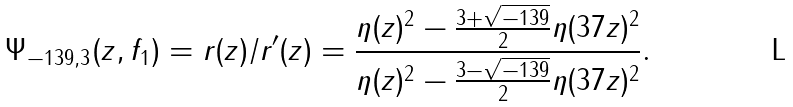Convert formula to latex. <formula><loc_0><loc_0><loc_500><loc_500>\Psi _ { - 1 3 9 , 3 } ( z , f _ { 1 } ) = r ( z ) / r ^ { \prime } ( z ) = \frac { \eta ( z ) ^ { 2 } - \frac { 3 + \sqrt { - 1 3 9 } } { 2 } \eta ( 3 7 z ) ^ { 2 } } { \eta ( z ) ^ { 2 } - \frac { 3 - \sqrt { - 1 3 9 } } { 2 } \eta ( 3 7 z ) ^ { 2 } } .</formula> 